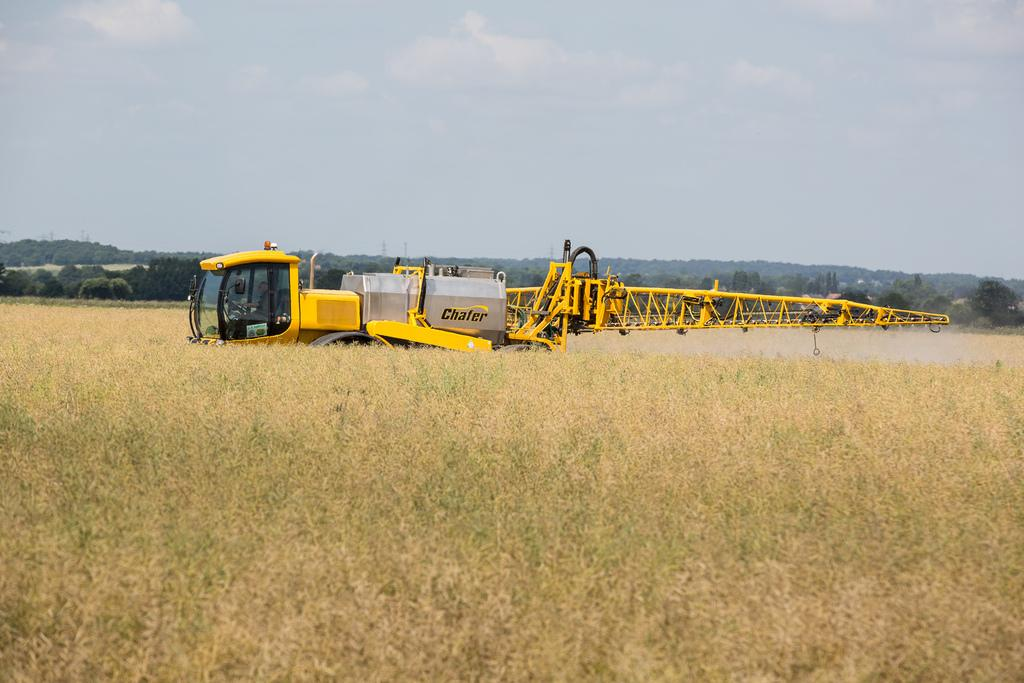What type of machinery is visible in the image? There is a chafer machinery in the image. What else can be seen in the image besides the machinery? There are plants in the image. What is visible in the background of the image? There are trees and the sky in the background of the image. What can be observed in the sky? Clouds are present in the sky. Where are the icicles hanging from in the image? There are no icicles present in the image. What achievements has the achiever accomplished in the image? There is no achiever or any achievements depicted in the image. 